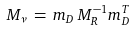<formula> <loc_0><loc_0><loc_500><loc_500>M _ { \nu } \, = \, m _ { D } \, M _ { R } ^ { - 1 } m _ { D } ^ { T }</formula> 